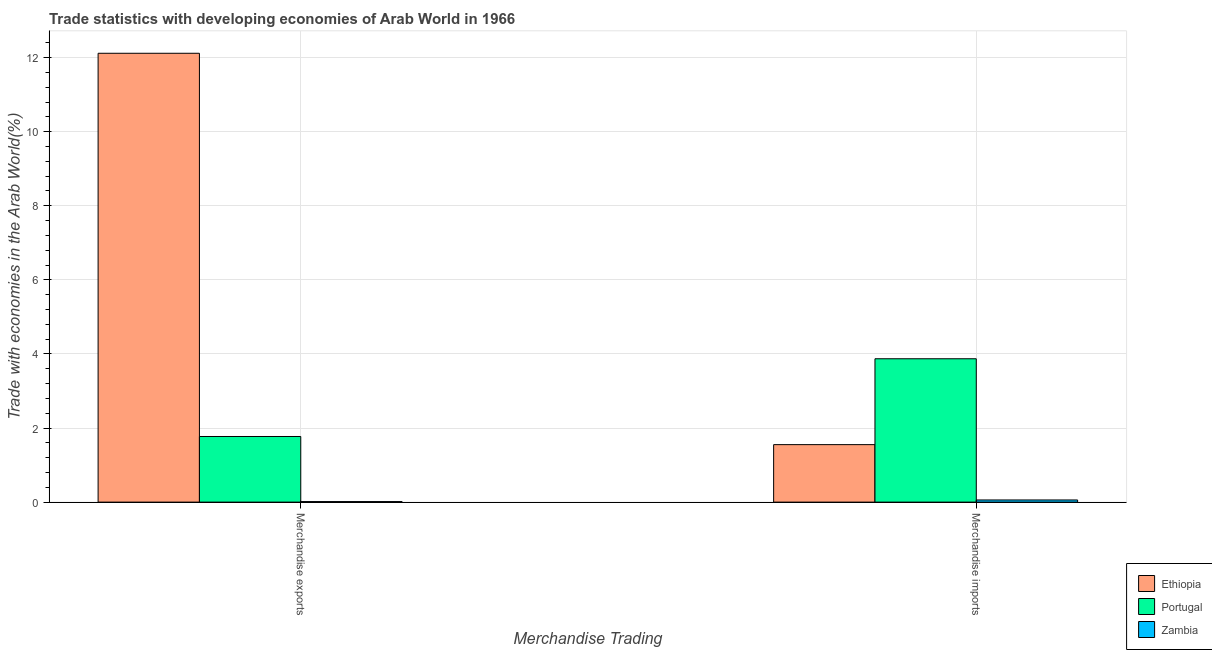How many groups of bars are there?
Give a very brief answer. 2. How many bars are there on the 1st tick from the right?
Give a very brief answer. 3. What is the label of the 2nd group of bars from the left?
Provide a succinct answer. Merchandise imports. What is the merchandise imports in Portugal?
Give a very brief answer. 3.87. Across all countries, what is the maximum merchandise exports?
Your answer should be very brief. 12.12. Across all countries, what is the minimum merchandise imports?
Ensure brevity in your answer.  0.06. In which country was the merchandise exports maximum?
Ensure brevity in your answer.  Ethiopia. In which country was the merchandise imports minimum?
Ensure brevity in your answer.  Zambia. What is the total merchandise imports in the graph?
Provide a succinct answer. 5.48. What is the difference between the merchandise imports in Ethiopia and that in Zambia?
Offer a very short reply. 1.49. What is the difference between the merchandise imports in Ethiopia and the merchandise exports in Zambia?
Provide a succinct answer. 1.54. What is the average merchandise exports per country?
Offer a terse response. 4.63. What is the difference between the merchandise exports and merchandise imports in Zambia?
Offer a terse response. -0.04. What is the ratio of the merchandise exports in Ethiopia to that in Zambia?
Provide a succinct answer. 836.23. What does the 3rd bar from the right in Merchandise imports represents?
Provide a short and direct response. Ethiopia. Are the values on the major ticks of Y-axis written in scientific E-notation?
Make the answer very short. No. Does the graph contain grids?
Provide a short and direct response. Yes. Where does the legend appear in the graph?
Give a very brief answer. Bottom right. What is the title of the graph?
Give a very brief answer. Trade statistics with developing economies of Arab World in 1966. What is the label or title of the X-axis?
Give a very brief answer. Merchandise Trading. What is the label or title of the Y-axis?
Your answer should be very brief. Trade with economies in the Arab World(%). What is the Trade with economies in the Arab World(%) in Ethiopia in Merchandise exports?
Provide a short and direct response. 12.12. What is the Trade with economies in the Arab World(%) of Portugal in Merchandise exports?
Offer a very short reply. 1.77. What is the Trade with economies in the Arab World(%) in Zambia in Merchandise exports?
Keep it short and to the point. 0.01. What is the Trade with economies in the Arab World(%) in Ethiopia in Merchandise imports?
Provide a succinct answer. 1.55. What is the Trade with economies in the Arab World(%) in Portugal in Merchandise imports?
Provide a succinct answer. 3.87. What is the Trade with economies in the Arab World(%) of Zambia in Merchandise imports?
Provide a succinct answer. 0.06. Across all Merchandise Trading, what is the maximum Trade with economies in the Arab World(%) of Ethiopia?
Keep it short and to the point. 12.12. Across all Merchandise Trading, what is the maximum Trade with economies in the Arab World(%) of Portugal?
Provide a short and direct response. 3.87. Across all Merchandise Trading, what is the maximum Trade with economies in the Arab World(%) of Zambia?
Offer a very short reply. 0.06. Across all Merchandise Trading, what is the minimum Trade with economies in the Arab World(%) in Ethiopia?
Ensure brevity in your answer.  1.55. Across all Merchandise Trading, what is the minimum Trade with economies in the Arab World(%) in Portugal?
Your response must be concise. 1.77. Across all Merchandise Trading, what is the minimum Trade with economies in the Arab World(%) in Zambia?
Make the answer very short. 0.01. What is the total Trade with economies in the Arab World(%) of Ethiopia in the graph?
Make the answer very short. 13.67. What is the total Trade with economies in the Arab World(%) of Portugal in the graph?
Make the answer very short. 5.64. What is the total Trade with economies in the Arab World(%) in Zambia in the graph?
Your response must be concise. 0.07. What is the difference between the Trade with economies in the Arab World(%) of Ethiopia in Merchandise exports and that in Merchandise imports?
Ensure brevity in your answer.  10.56. What is the difference between the Trade with economies in the Arab World(%) of Portugal in Merchandise exports and that in Merchandise imports?
Give a very brief answer. -2.1. What is the difference between the Trade with economies in the Arab World(%) of Zambia in Merchandise exports and that in Merchandise imports?
Keep it short and to the point. -0.04. What is the difference between the Trade with economies in the Arab World(%) in Ethiopia in Merchandise exports and the Trade with economies in the Arab World(%) in Portugal in Merchandise imports?
Give a very brief answer. 8.25. What is the difference between the Trade with economies in the Arab World(%) of Ethiopia in Merchandise exports and the Trade with economies in the Arab World(%) of Zambia in Merchandise imports?
Provide a succinct answer. 12.06. What is the difference between the Trade with economies in the Arab World(%) of Portugal in Merchandise exports and the Trade with economies in the Arab World(%) of Zambia in Merchandise imports?
Your answer should be very brief. 1.71. What is the average Trade with economies in the Arab World(%) in Ethiopia per Merchandise Trading?
Your answer should be compact. 6.83. What is the average Trade with economies in the Arab World(%) of Portugal per Merchandise Trading?
Offer a terse response. 2.82. What is the average Trade with economies in the Arab World(%) of Zambia per Merchandise Trading?
Ensure brevity in your answer.  0.04. What is the difference between the Trade with economies in the Arab World(%) in Ethiopia and Trade with economies in the Arab World(%) in Portugal in Merchandise exports?
Ensure brevity in your answer.  10.34. What is the difference between the Trade with economies in the Arab World(%) of Ethiopia and Trade with economies in the Arab World(%) of Zambia in Merchandise exports?
Your answer should be very brief. 12.1. What is the difference between the Trade with economies in the Arab World(%) in Portugal and Trade with economies in the Arab World(%) in Zambia in Merchandise exports?
Give a very brief answer. 1.76. What is the difference between the Trade with economies in the Arab World(%) of Ethiopia and Trade with economies in the Arab World(%) of Portugal in Merchandise imports?
Your answer should be very brief. -2.32. What is the difference between the Trade with economies in the Arab World(%) in Ethiopia and Trade with economies in the Arab World(%) in Zambia in Merchandise imports?
Offer a very short reply. 1.49. What is the difference between the Trade with economies in the Arab World(%) of Portugal and Trade with economies in the Arab World(%) of Zambia in Merchandise imports?
Keep it short and to the point. 3.81. What is the ratio of the Trade with economies in the Arab World(%) of Ethiopia in Merchandise exports to that in Merchandise imports?
Your response must be concise. 7.81. What is the ratio of the Trade with economies in the Arab World(%) in Portugal in Merchandise exports to that in Merchandise imports?
Your answer should be compact. 0.46. What is the ratio of the Trade with economies in the Arab World(%) of Zambia in Merchandise exports to that in Merchandise imports?
Offer a terse response. 0.25. What is the difference between the highest and the second highest Trade with economies in the Arab World(%) in Ethiopia?
Ensure brevity in your answer.  10.56. What is the difference between the highest and the second highest Trade with economies in the Arab World(%) of Portugal?
Provide a short and direct response. 2.1. What is the difference between the highest and the second highest Trade with economies in the Arab World(%) of Zambia?
Offer a very short reply. 0.04. What is the difference between the highest and the lowest Trade with economies in the Arab World(%) in Ethiopia?
Give a very brief answer. 10.56. What is the difference between the highest and the lowest Trade with economies in the Arab World(%) in Portugal?
Your answer should be compact. 2.1. What is the difference between the highest and the lowest Trade with economies in the Arab World(%) of Zambia?
Provide a succinct answer. 0.04. 